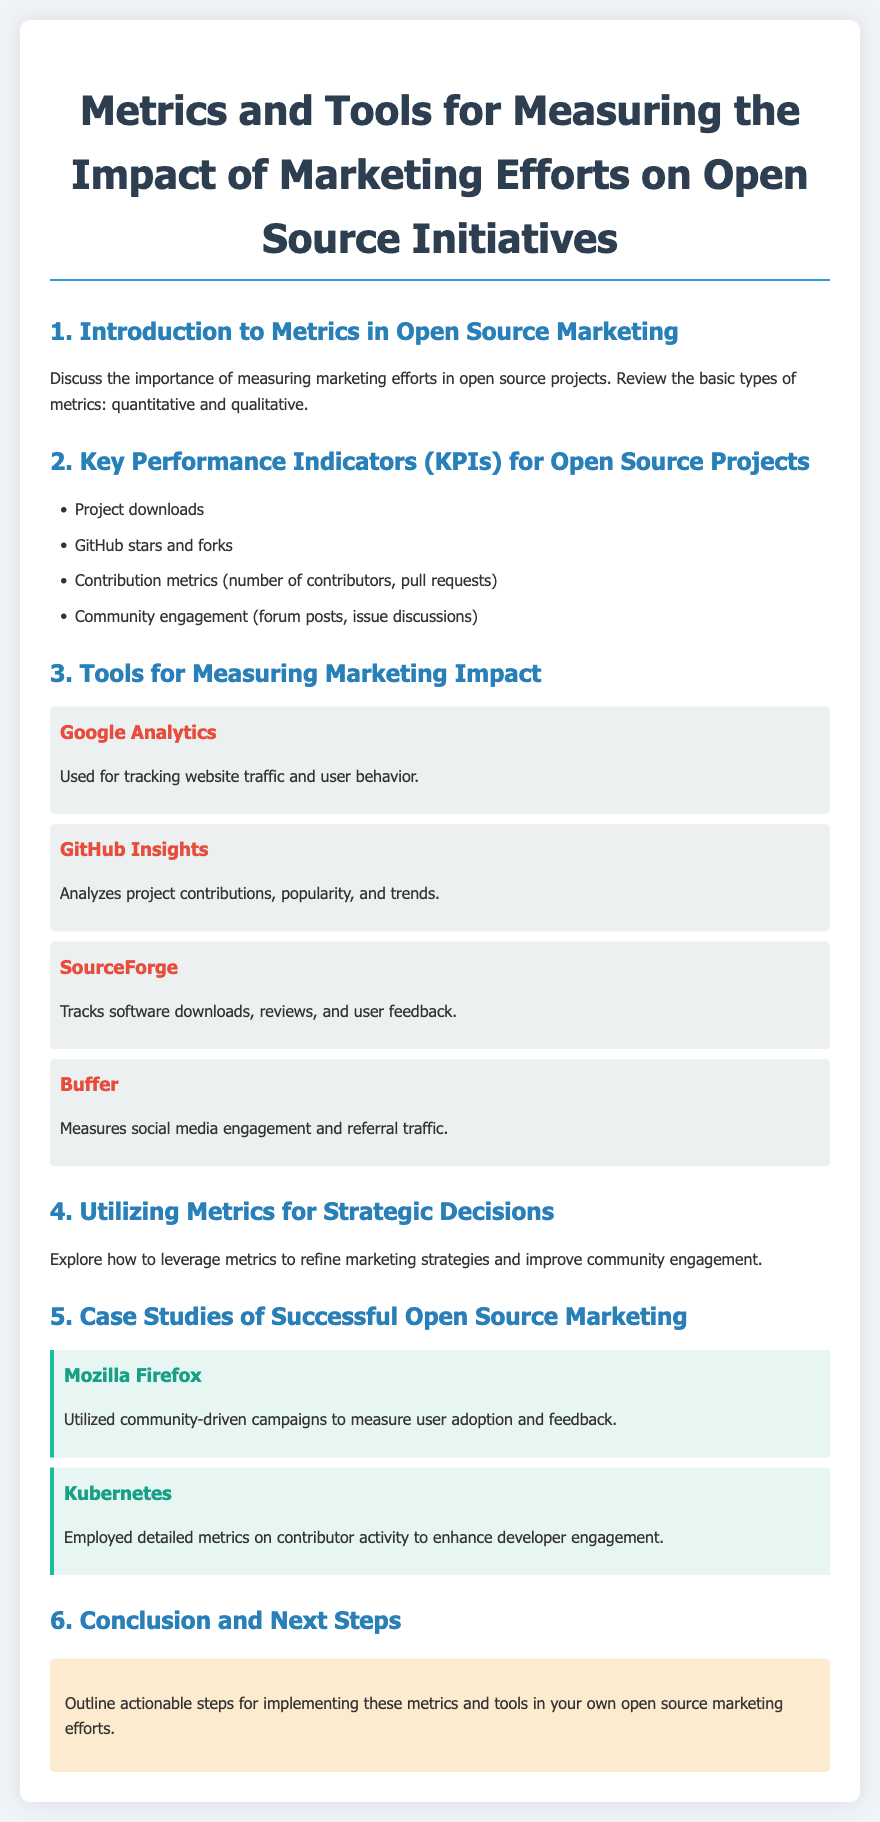what is the title of the document? The title is clearly stated at the beginning of the document for easy reference.
Answer: Metrics and Tools for Measuring the Impact of Marketing Efforts on Open Source Initiatives how many key performance indicators are listed? The number of key performance indicators mentioned in the document can be counted within the relevant section.
Answer: 4 which tool is used for tracking website traffic? The document specifies which tool is employed for tracking particular metrics in the section devoted to measurement tools.
Answer: Google Analytics name one case study mentioned. The case studies section provides examples of successful open-source marketing initiatives for reference.
Answer: Mozilla Firefox what type of metrics are reviewed in the introduction? The introduction identifies specific types of metrics as part of the discussion on marketing efforts.
Answer: quantitative and qualitative what aspect of community engagement is discussed as a key performance indicator? The document highlights various ways community engagement is measured in terms of open source initiatives.
Answer: forum posts which tool measures social media engagement? The tools section details several tools utilized, including one dedicated to social media metrics.
Answer: Buffer how does Mozilla Firefox measure user adoption? The document provides insight into the strategies used by specific projects, such as Mozilla Firefox.
Answer: community-driven campaigns what is the main purpose of utilizing metrics as described in the document? The section on utilizing metrics aims to explain how they can impact marketing strategies and community involvement.
Answer: refine marketing strategies 